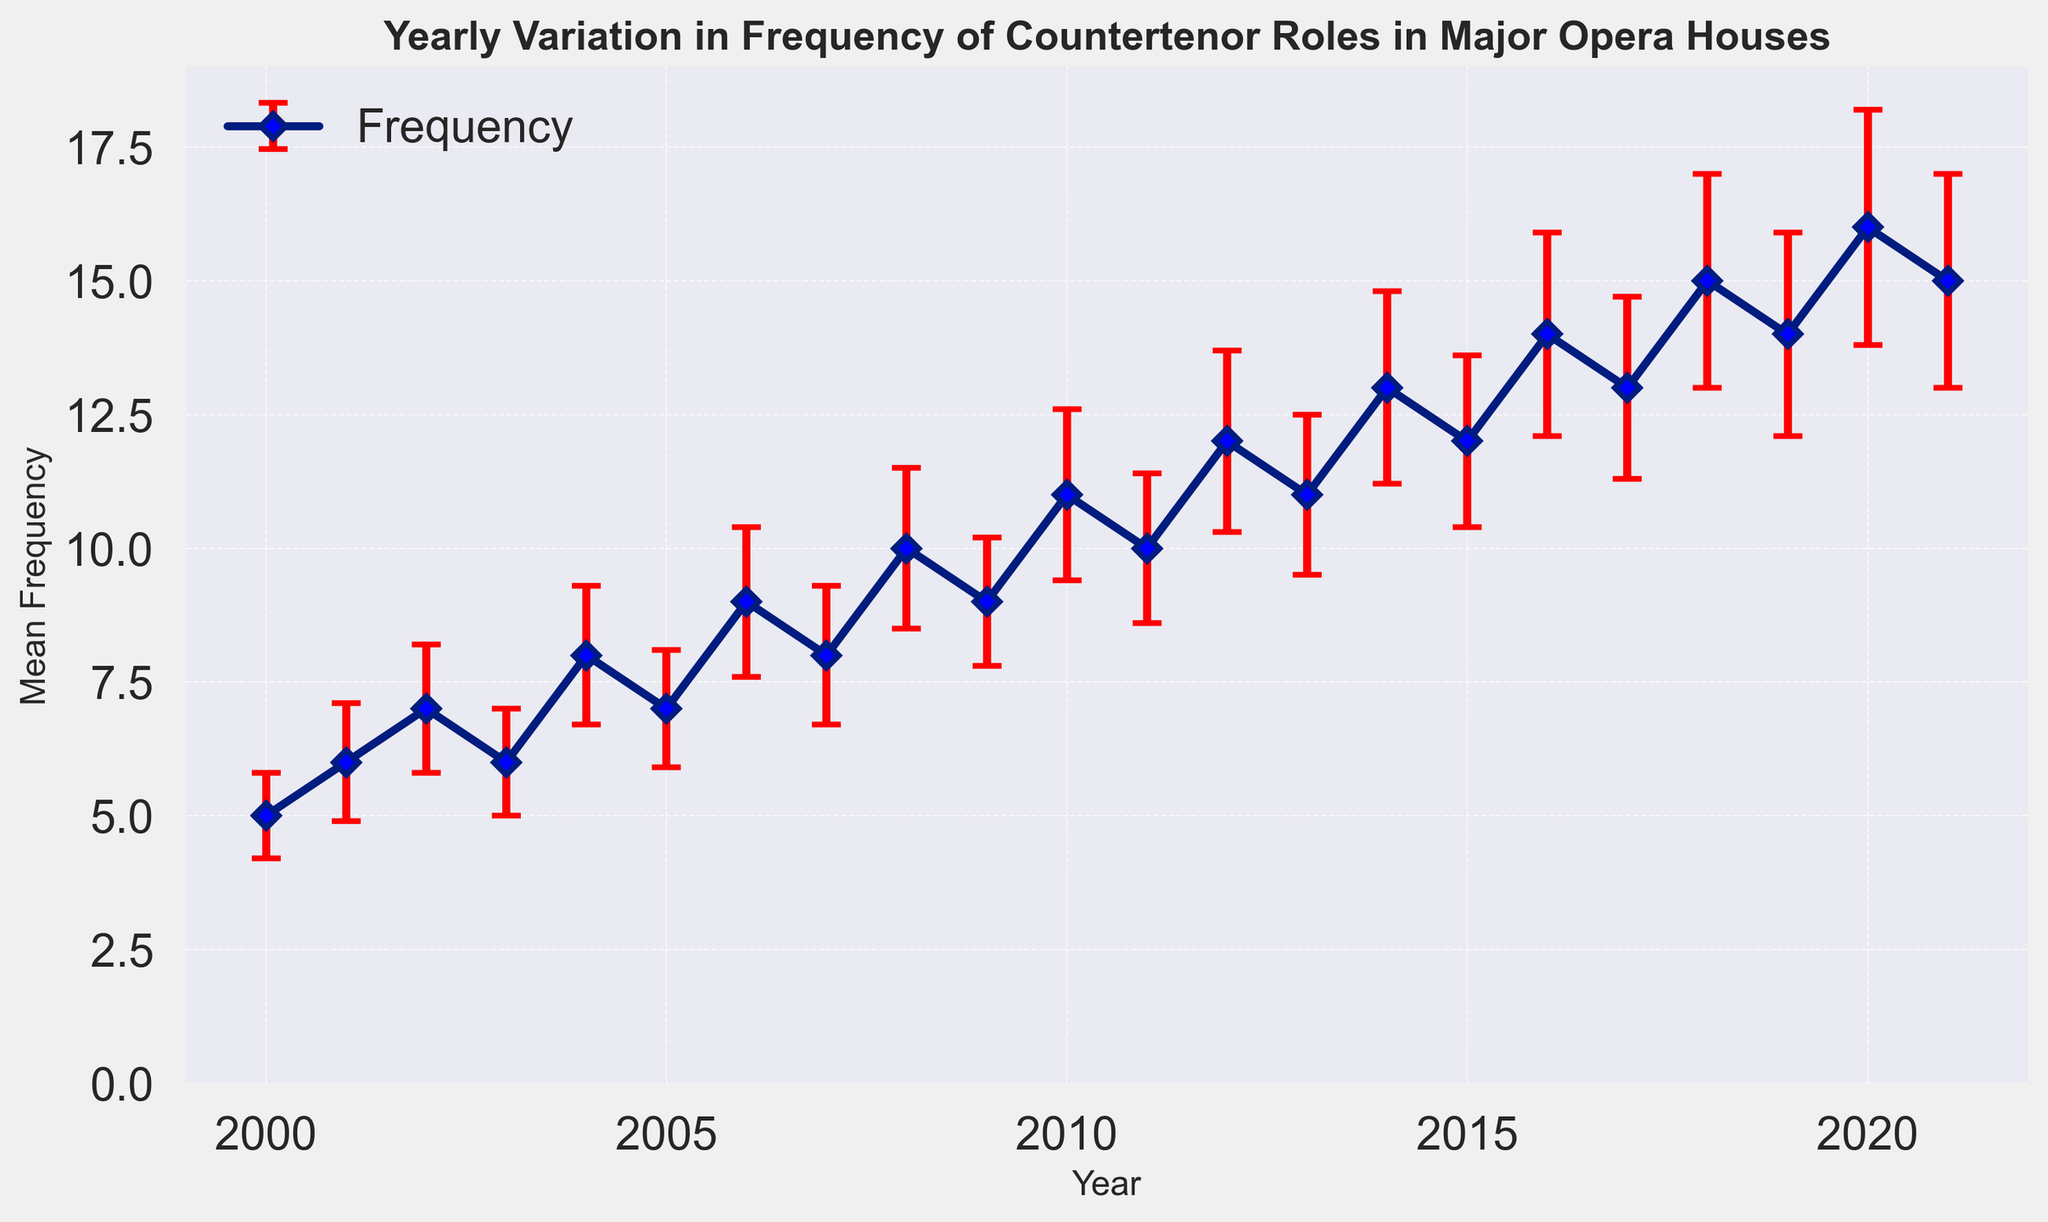How did the mean frequency of countertenor roles change from 2000 to 2021? From the figure, observe the trend line marked by the data points from 2000 to 2021. The mean frequency started at 5 in 2000 and increased to 15 in 2021, indicating a rising trend.
Answer: It increased from 5 to 15 In which year was the mean frequency of countertenor roles the highest? Look for the highest data point on the plot. The year with the highest point is 2020, with a mean frequency of 16.
Answer: 2020 Which years have equally high mean frequencies of countertenor roles? Identify the years that have data points at the same height on the vertical axis. The years 2011, 2013, 2015, and 2017 all share a mean frequency of 10; the years 2018 and 2021 have a mean frequency of 15; the years 2007 and 2009 have a mean frequency of 9.
Answer: 2011, 2013, 2015, 2017 for 10; 2018, 2021 for 15; 2007, 2009 for 9 What is the difference in mean frequency between 2005 and 2012? Locate the mean frequency values for the years 2005 (7) and 2012 (12). Then, calculate the difference: 12 - 7 = 5.
Answer: 5 Is the mean frequency of countertenor roles generally increasing, decreasing, or stable over the years? Analyze the general trend of the data points from 2000 to 2021. Most data points form an upward trend line indicating an increase.
Answer: Increasing How many times did the mean frequency exceed 10? Count the data points that are above the value of 10 on the vertical axis. The mean frequency exceeded 10 in the years 2012, 2014, 2016, 2018, 2019, 2020, and 2021, which totals 7 times.
Answer: 7 times Which year had the largest standard deviation in the frequency of countertenor roles? Look for the longest error bar in the figure, which represents the standard deviation. The longest error bar is in 2020, indicating a standard deviation of 2.2.
Answer: 2020 What was the mean frequency of countertenor roles in 2015 compared to 2004? Check the data points for 2015 (12) and 2004 (8), then compare these values.
Answer: 2015 is higher by 4 Did any years show a decrease in mean frequency compared to the previous year? Examine the trend line, specifically looking for points that descend. The year 2017 witnessed a slight drop compared to 2016 (14 to 13).
Answer: Yes, 2017 compared to 2016 What's the average mean frequency of the countertenor roles for the entire period? Sum all the mean frequency values and divide by the number of years (from 2000 to 2021, 22 years): (5 + 6 + 7 + 6 + 8 + 7 + 9 + 8 + 10 + 9 + 11 + 10 + 12 + 11 + 13 + 12 + 14 + 13 + 15 + 14 + 16 + 15) / 22 = 10.18.
Answer: 10.18 